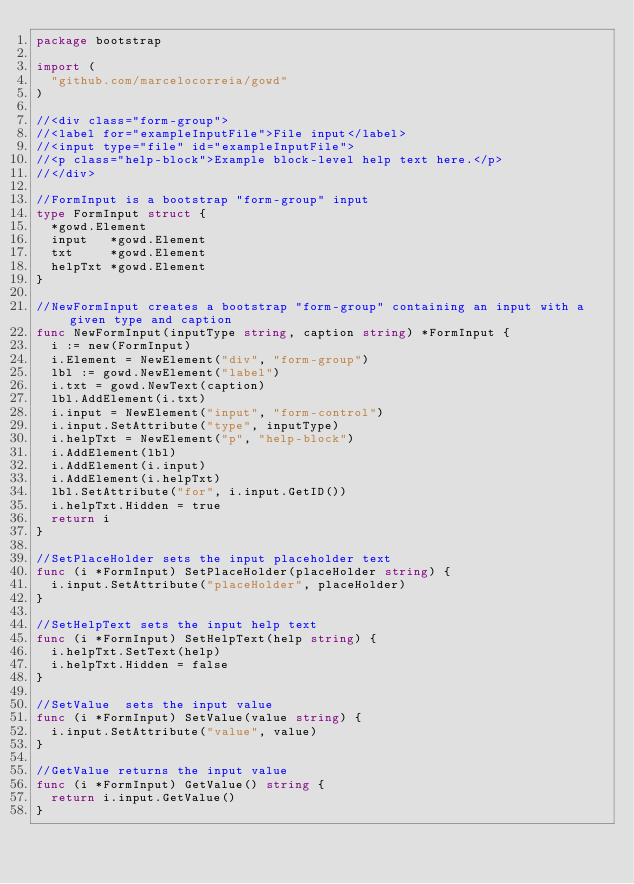Convert code to text. <code><loc_0><loc_0><loc_500><loc_500><_Go_>package bootstrap

import (
	"github.com/marcelocorreia/gowd"
)

//<div class="form-group">
//<label for="exampleInputFile">File input</label>
//<input type="file" id="exampleInputFile">
//<p class="help-block">Example block-level help text here.</p>
//</div>

//FormInput is a bootstrap "form-group" input
type FormInput struct {
	*gowd.Element
	input   *gowd.Element
	txt     *gowd.Element
	helpTxt *gowd.Element
}

//NewFormInput creates a bootstrap "form-group" containing an input with a given type and caption
func NewFormInput(inputType string, caption string) *FormInput {
	i := new(FormInput)
	i.Element = NewElement("div", "form-group")
	lbl := gowd.NewElement("label")
	i.txt = gowd.NewText(caption)
	lbl.AddElement(i.txt)
	i.input = NewElement("input", "form-control")
	i.input.SetAttribute("type", inputType)
	i.helpTxt = NewElement("p", "help-block")
	i.AddElement(lbl)
	i.AddElement(i.input)
	i.AddElement(i.helpTxt)
	lbl.SetAttribute("for", i.input.GetID())
	i.helpTxt.Hidden = true
	return i
}

//SetPlaceHolder sets the input placeholder text
func (i *FormInput) SetPlaceHolder(placeHolder string) {
	i.input.SetAttribute("placeHolder", placeHolder)
}

//SetHelpText sets the input help text
func (i *FormInput) SetHelpText(help string) {
	i.helpTxt.SetText(help)
	i.helpTxt.Hidden = false
}

//SetValue  sets the input value
func (i *FormInput) SetValue(value string) {
	i.input.SetAttribute("value", value)
}

//GetValue returns the input value
func (i *FormInput) GetValue() string {
	return i.input.GetValue()
}
</code> 